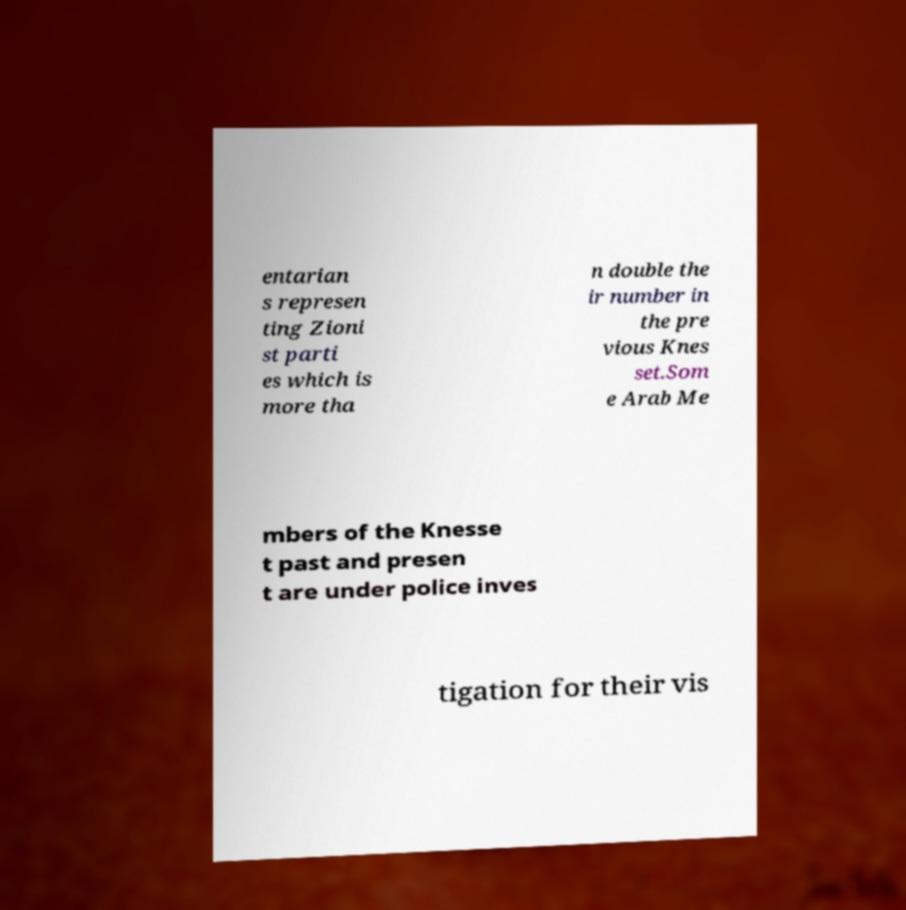Can you accurately transcribe the text from the provided image for me? entarian s represen ting Zioni st parti es which is more tha n double the ir number in the pre vious Knes set.Som e Arab Me mbers of the Knesse t past and presen t are under police inves tigation for their vis 